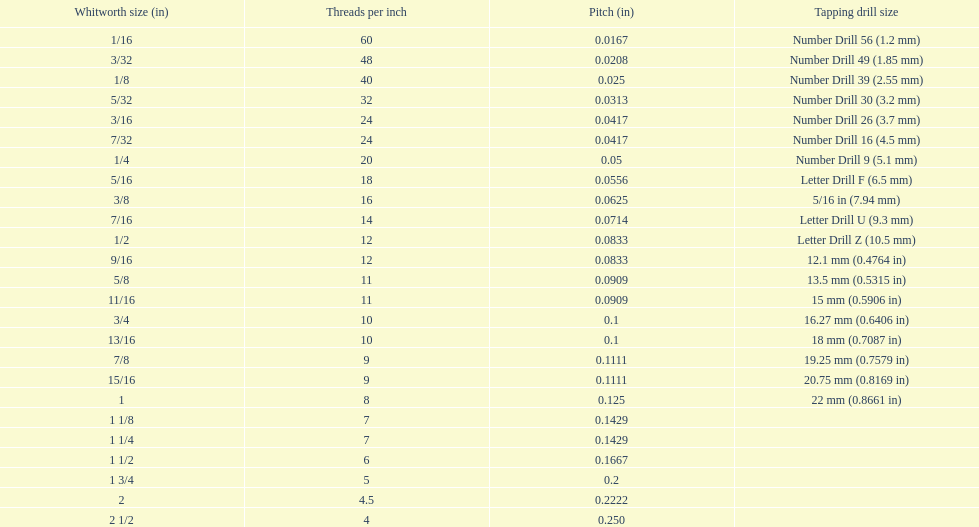What is the total of the first two core diameters? 0.1083. 